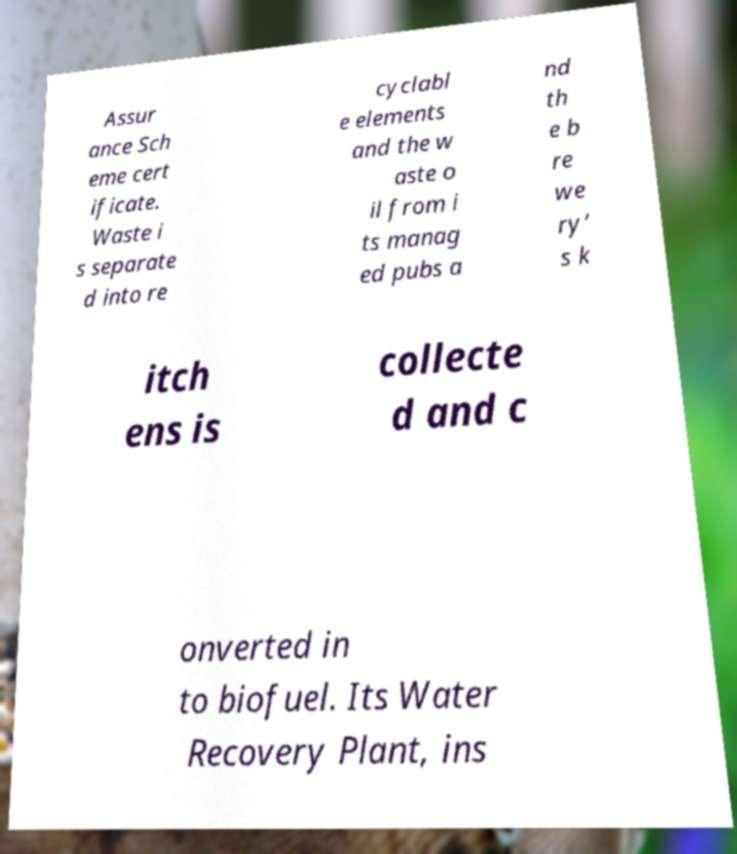Can you read and provide the text displayed in the image?This photo seems to have some interesting text. Can you extract and type it out for me? Assur ance Sch eme cert ificate. Waste i s separate d into re cyclabl e elements and the w aste o il from i ts manag ed pubs a nd th e b re we ry’ s k itch ens is collecte d and c onverted in to biofuel. Its Water Recovery Plant, ins 